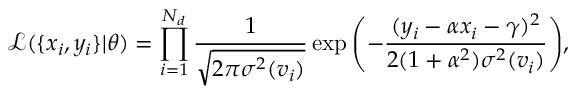<formula> <loc_0><loc_0><loc_500><loc_500>\mathcal { L } ( \{ x _ { i } , y _ { i } \} | \theta ) = \prod _ { i = 1 } ^ { N _ { d } } \frac { 1 } { \sqrt { 2 \pi \sigma ^ { 2 } ( v _ { i } ) } } \exp { \left ( - \frac { ( y _ { i } - \alpha x _ { i } - \gamma ) ^ { 2 } } { 2 ( 1 + \alpha ^ { 2 } ) \sigma ^ { 2 } ( v _ { i } ) } \right ) } ,</formula> 